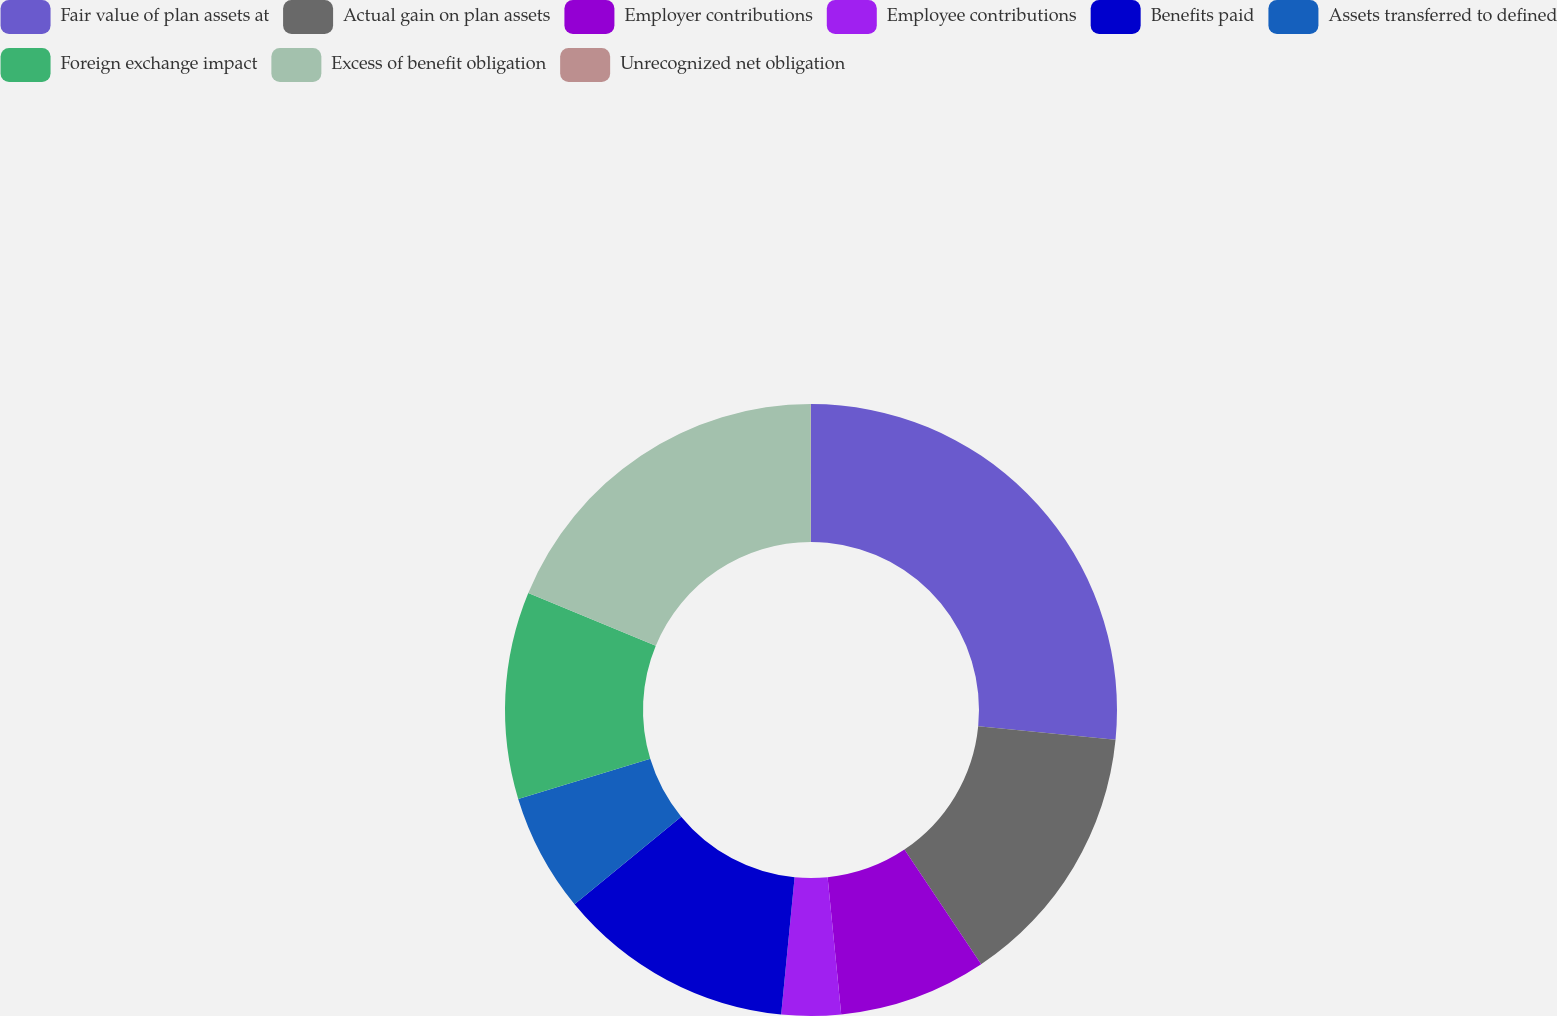Convert chart. <chart><loc_0><loc_0><loc_500><loc_500><pie_chart><fcel>Fair value of plan assets at<fcel>Actual gain on plan assets<fcel>Employer contributions<fcel>Employee contributions<fcel>Benefits paid<fcel>Assets transferred to defined<fcel>Foreign exchange impact<fcel>Excess of benefit obligation<fcel>Unrecognized net obligation<nl><fcel>26.55%<fcel>14.06%<fcel>7.81%<fcel>3.13%<fcel>12.5%<fcel>6.25%<fcel>10.94%<fcel>18.74%<fcel>0.01%<nl></chart> 